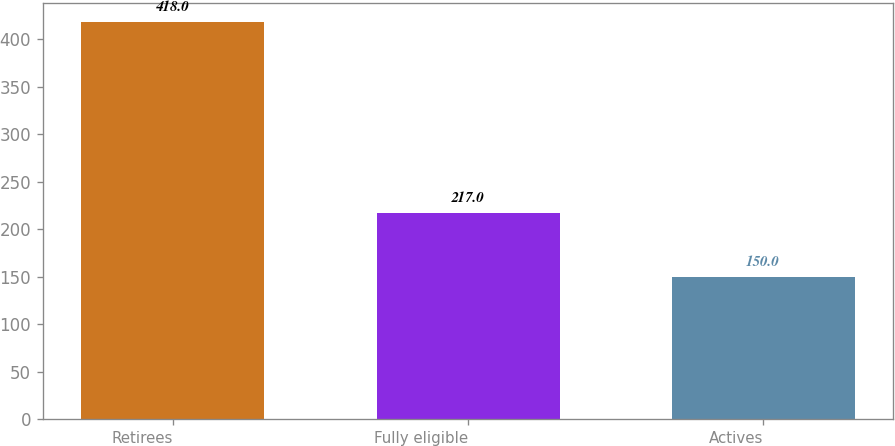Convert chart to OTSL. <chart><loc_0><loc_0><loc_500><loc_500><bar_chart><fcel>Retirees<fcel>Fully eligible<fcel>Actives<nl><fcel>418<fcel>217<fcel>150<nl></chart> 